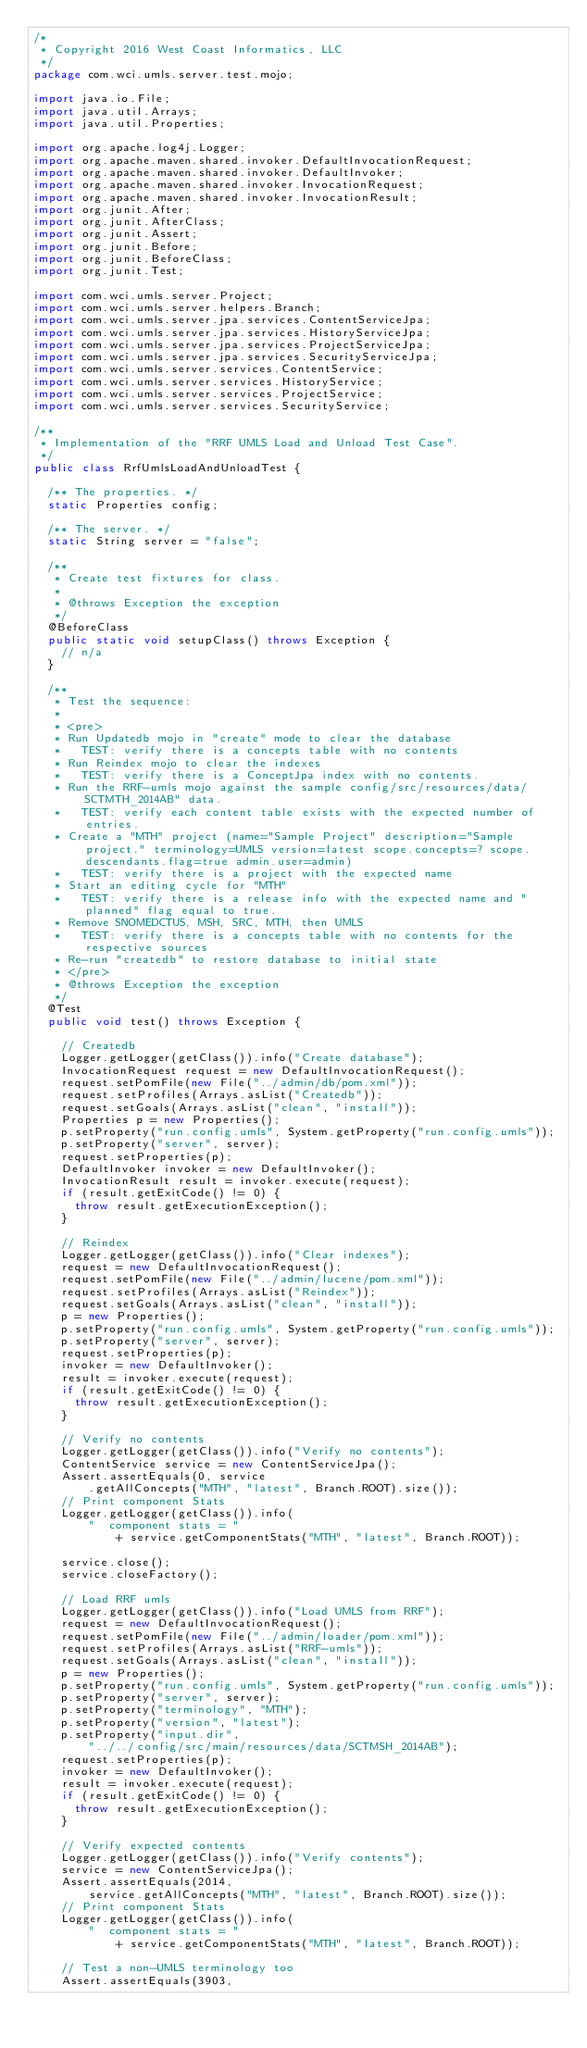Convert code to text. <code><loc_0><loc_0><loc_500><loc_500><_Java_>/*
 * Copyright 2016 West Coast Informatics, LLC
 */
package com.wci.umls.server.test.mojo;

import java.io.File;
import java.util.Arrays;
import java.util.Properties;

import org.apache.log4j.Logger;
import org.apache.maven.shared.invoker.DefaultInvocationRequest;
import org.apache.maven.shared.invoker.DefaultInvoker;
import org.apache.maven.shared.invoker.InvocationRequest;
import org.apache.maven.shared.invoker.InvocationResult;
import org.junit.After;
import org.junit.AfterClass;
import org.junit.Assert;
import org.junit.Before;
import org.junit.BeforeClass;
import org.junit.Test;

import com.wci.umls.server.Project;
import com.wci.umls.server.helpers.Branch;
import com.wci.umls.server.jpa.services.ContentServiceJpa;
import com.wci.umls.server.jpa.services.HistoryServiceJpa;
import com.wci.umls.server.jpa.services.ProjectServiceJpa;
import com.wci.umls.server.jpa.services.SecurityServiceJpa;
import com.wci.umls.server.services.ContentService;
import com.wci.umls.server.services.HistoryService;
import com.wci.umls.server.services.ProjectService;
import com.wci.umls.server.services.SecurityService;

/**
 * Implementation of the "RRF UMLS Load and Unload Test Case".
 */
public class RrfUmlsLoadAndUnloadTest {

  /** The properties. */
  static Properties config;

  /** The server. */
  static String server = "false";

  /**
   * Create test fixtures for class.
   *
   * @throws Exception the exception
   */
  @BeforeClass
  public static void setupClass() throws Exception {
    // n/a
  }

  /**
   * Test the sequence:
   * 
   * <pre>
   * Run Updatedb mojo in "create" mode to clear the database
   *   TEST: verify there is a concepts table with no contents
   * Run Reindex mojo to clear the indexes
   *   TEST: verify there is a ConceptJpa index with no contents.
   * Run the RRF-umls mojo against the sample config/src/resources/data/SCTMTH_2014AB" data.
   *   TEST: verify each content table exists with the expected number of entries.
   * Create a "MTH" project (name="Sample Project" description="Sample project." terminology=UMLS version=latest scope.concepts=? scope.descendants.flag=true admin.user=admin)
   *   TEST: verify there is a project with the expected name
   * Start an editing cycle for "MTH"
   *   TEST: verify there is a release info with the expected name and "planned" flag equal to true.
   * Remove SNOMEDCTUS, MSH, SRC, MTH, then UMLS
   *   TEST: verify there is a concepts table with no contents for the respective sources
   * Re-run "createdb" to restore database to initial state
   * </pre>
   * @throws Exception the exception
   */
  @Test
  public void test() throws Exception {

    // Createdb
    Logger.getLogger(getClass()).info("Create database");
    InvocationRequest request = new DefaultInvocationRequest();
    request.setPomFile(new File("../admin/db/pom.xml"));
    request.setProfiles(Arrays.asList("Createdb"));
    request.setGoals(Arrays.asList("clean", "install"));
    Properties p = new Properties();
    p.setProperty("run.config.umls", System.getProperty("run.config.umls"));
    p.setProperty("server", server);
    request.setProperties(p);
    DefaultInvoker invoker = new DefaultInvoker();
    InvocationResult result = invoker.execute(request);
    if (result.getExitCode() != 0) {
      throw result.getExecutionException();
    }

    // Reindex
    Logger.getLogger(getClass()).info("Clear indexes");
    request = new DefaultInvocationRequest();
    request.setPomFile(new File("../admin/lucene/pom.xml"));
    request.setProfiles(Arrays.asList("Reindex"));
    request.setGoals(Arrays.asList("clean", "install"));
    p = new Properties();
    p.setProperty("run.config.umls", System.getProperty("run.config.umls"));
    p.setProperty("server", server);
    request.setProperties(p);
    invoker = new DefaultInvoker();
    result = invoker.execute(request);
    if (result.getExitCode() != 0) {
      throw result.getExecutionException();
    }

    // Verify no contents
    Logger.getLogger(getClass()).info("Verify no contents");
    ContentService service = new ContentServiceJpa();
    Assert.assertEquals(0, service
        .getAllConcepts("MTH", "latest", Branch.ROOT).size());
    // Print component Stats
    Logger.getLogger(getClass()).info(
        "  component stats = "
            + service.getComponentStats("MTH", "latest", Branch.ROOT));

    service.close();
    service.closeFactory();

    // Load RRF umls
    Logger.getLogger(getClass()).info("Load UMLS from RRF");
    request = new DefaultInvocationRequest();
    request.setPomFile(new File("../admin/loader/pom.xml"));
    request.setProfiles(Arrays.asList("RRF-umls"));
    request.setGoals(Arrays.asList("clean", "install"));
    p = new Properties();
    p.setProperty("run.config.umls", System.getProperty("run.config.umls"));
    p.setProperty("server", server);
    p.setProperty("terminology", "MTH");
    p.setProperty("version", "latest");
    p.setProperty("input.dir",
        "../../config/src/main/resources/data/SCTMSH_2014AB");
    request.setProperties(p);
    invoker = new DefaultInvoker();
    result = invoker.execute(request);
    if (result.getExitCode() != 0) {
      throw result.getExecutionException();
    }

    // Verify expected contents
    Logger.getLogger(getClass()).info("Verify contents");
    service = new ContentServiceJpa();
    Assert.assertEquals(2014,
        service.getAllConcepts("MTH", "latest", Branch.ROOT).size());
    // Print component Stats
    Logger.getLogger(getClass()).info(
        "  component stats = "
            + service.getComponentStats("MTH", "latest", Branch.ROOT));

    // Test a non-UMLS terminology too
    Assert.assertEquals(3903,</code> 